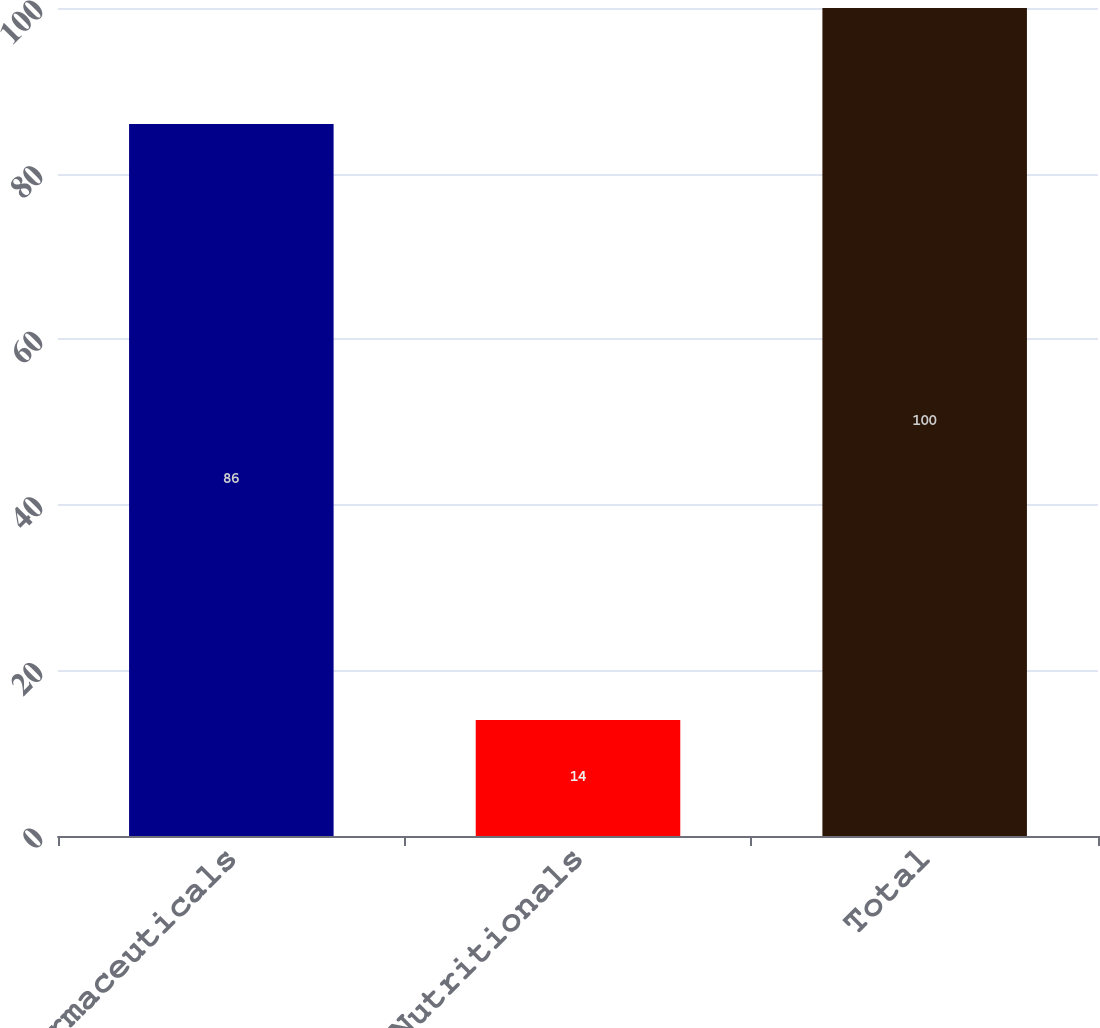Convert chart. <chart><loc_0><loc_0><loc_500><loc_500><bar_chart><fcel>Pharmaceuticals<fcel>Nutritionals<fcel>Total<nl><fcel>86<fcel>14<fcel>100<nl></chart> 